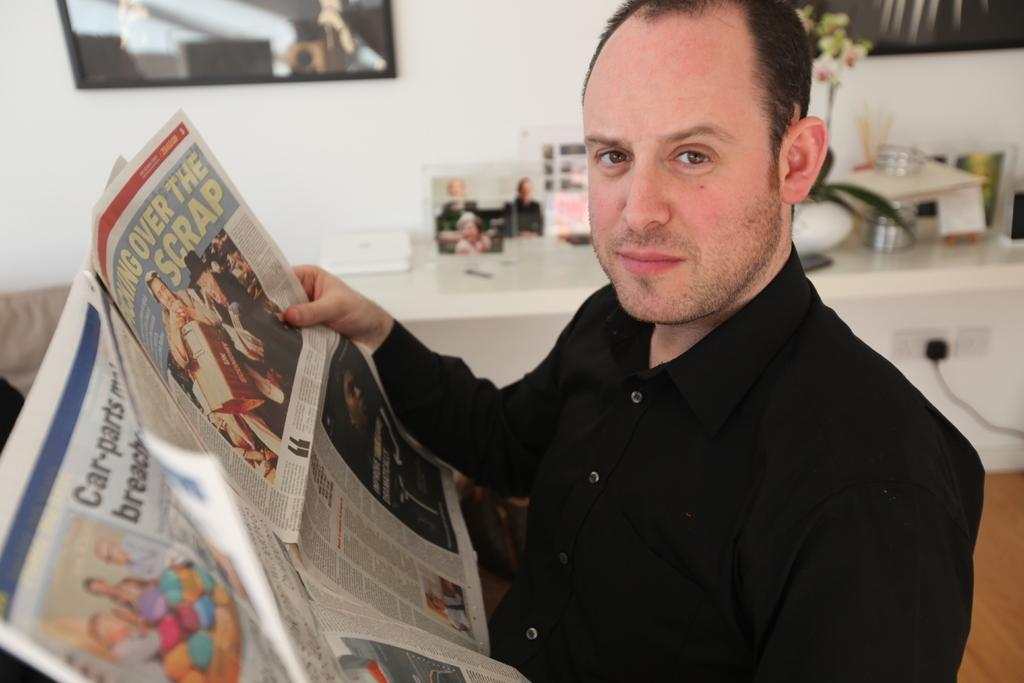<image>
Describe the image concisely. A man reading a newspaper with Scrap written on it. 